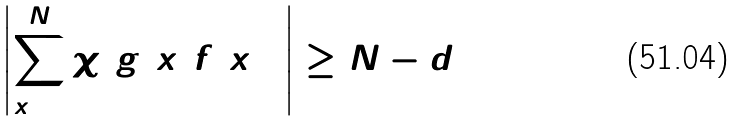<formula> <loc_0><loc_0><loc_500><loc_500>\left | \sum _ { x = 1 } ^ { N } \chi ( g ( x ) f ( x ) ) \right | \geq N - d</formula> 